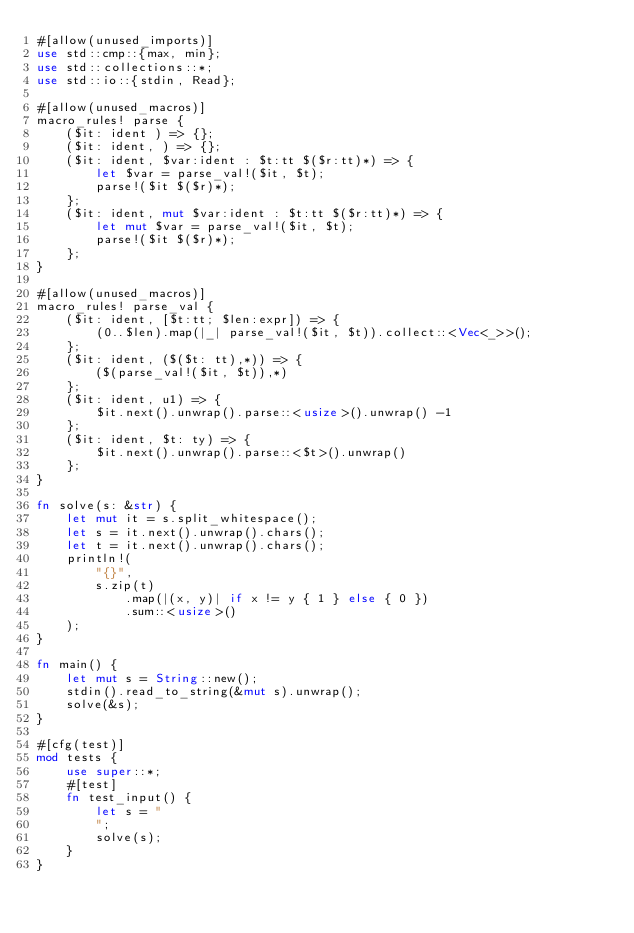Convert code to text. <code><loc_0><loc_0><loc_500><loc_500><_Rust_>#[allow(unused_imports)]
use std::cmp::{max, min};
use std::collections::*;
use std::io::{stdin, Read};

#[allow(unused_macros)]
macro_rules! parse {
    ($it: ident ) => {};
    ($it: ident, ) => {};
    ($it: ident, $var:ident : $t:tt $($r:tt)*) => {
        let $var = parse_val!($it, $t);
        parse!($it $($r)*);
    };
    ($it: ident, mut $var:ident : $t:tt $($r:tt)*) => {
        let mut $var = parse_val!($it, $t);
        parse!($it $($r)*);
    };
}

#[allow(unused_macros)]
macro_rules! parse_val {
    ($it: ident, [$t:tt; $len:expr]) => {
        (0..$len).map(|_| parse_val!($it, $t)).collect::<Vec<_>>();
    };
    ($it: ident, ($($t: tt),*)) => {
        ($(parse_val!($it, $t)),*)
    };
    ($it: ident, u1) => {
        $it.next().unwrap().parse::<usize>().unwrap() -1
    };
    ($it: ident, $t: ty) => {
        $it.next().unwrap().parse::<$t>().unwrap()
    };
}

fn solve(s: &str) {
    let mut it = s.split_whitespace();
    let s = it.next().unwrap().chars();
    let t = it.next().unwrap().chars();
    println!(
        "{}",
        s.zip(t)
            .map(|(x, y)| if x != y { 1 } else { 0 })
            .sum::<usize>()
    );
}

fn main() {
    let mut s = String::new();
    stdin().read_to_string(&mut s).unwrap();
    solve(&s);
}

#[cfg(test)]
mod tests {
    use super::*;
    #[test]
    fn test_input() {
        let s = "
        ";
        solve(s);
    }
}
</code> 